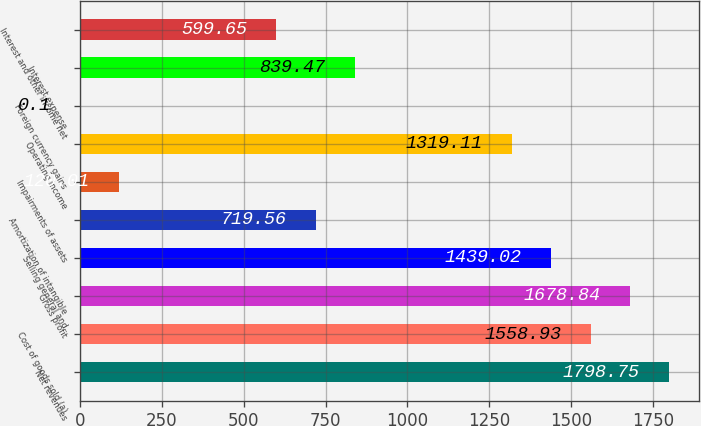<chart> <loc_0><loc_0><loc_500><loc_500><bar_chart><fcel>Net revenues<fcel>Cost of goods sold (a)<fcel>Gross profit<fcel>Selling general and<fcel>Amortization of intangible<fcel>Impairments of assets<fcel>Operating income<fcel>Foreign currency gains<fcel>Interest expense<fcel>Interest and other income net<nl><fcel>1798.75<fcel>1558.93<fcel>1678.84<fcel>1439.02<fcel>719.56<fcel>120.01<fcel>1319.11<fcel>0.1<fcel>839.47<fcel>599.65<nl></chart> 